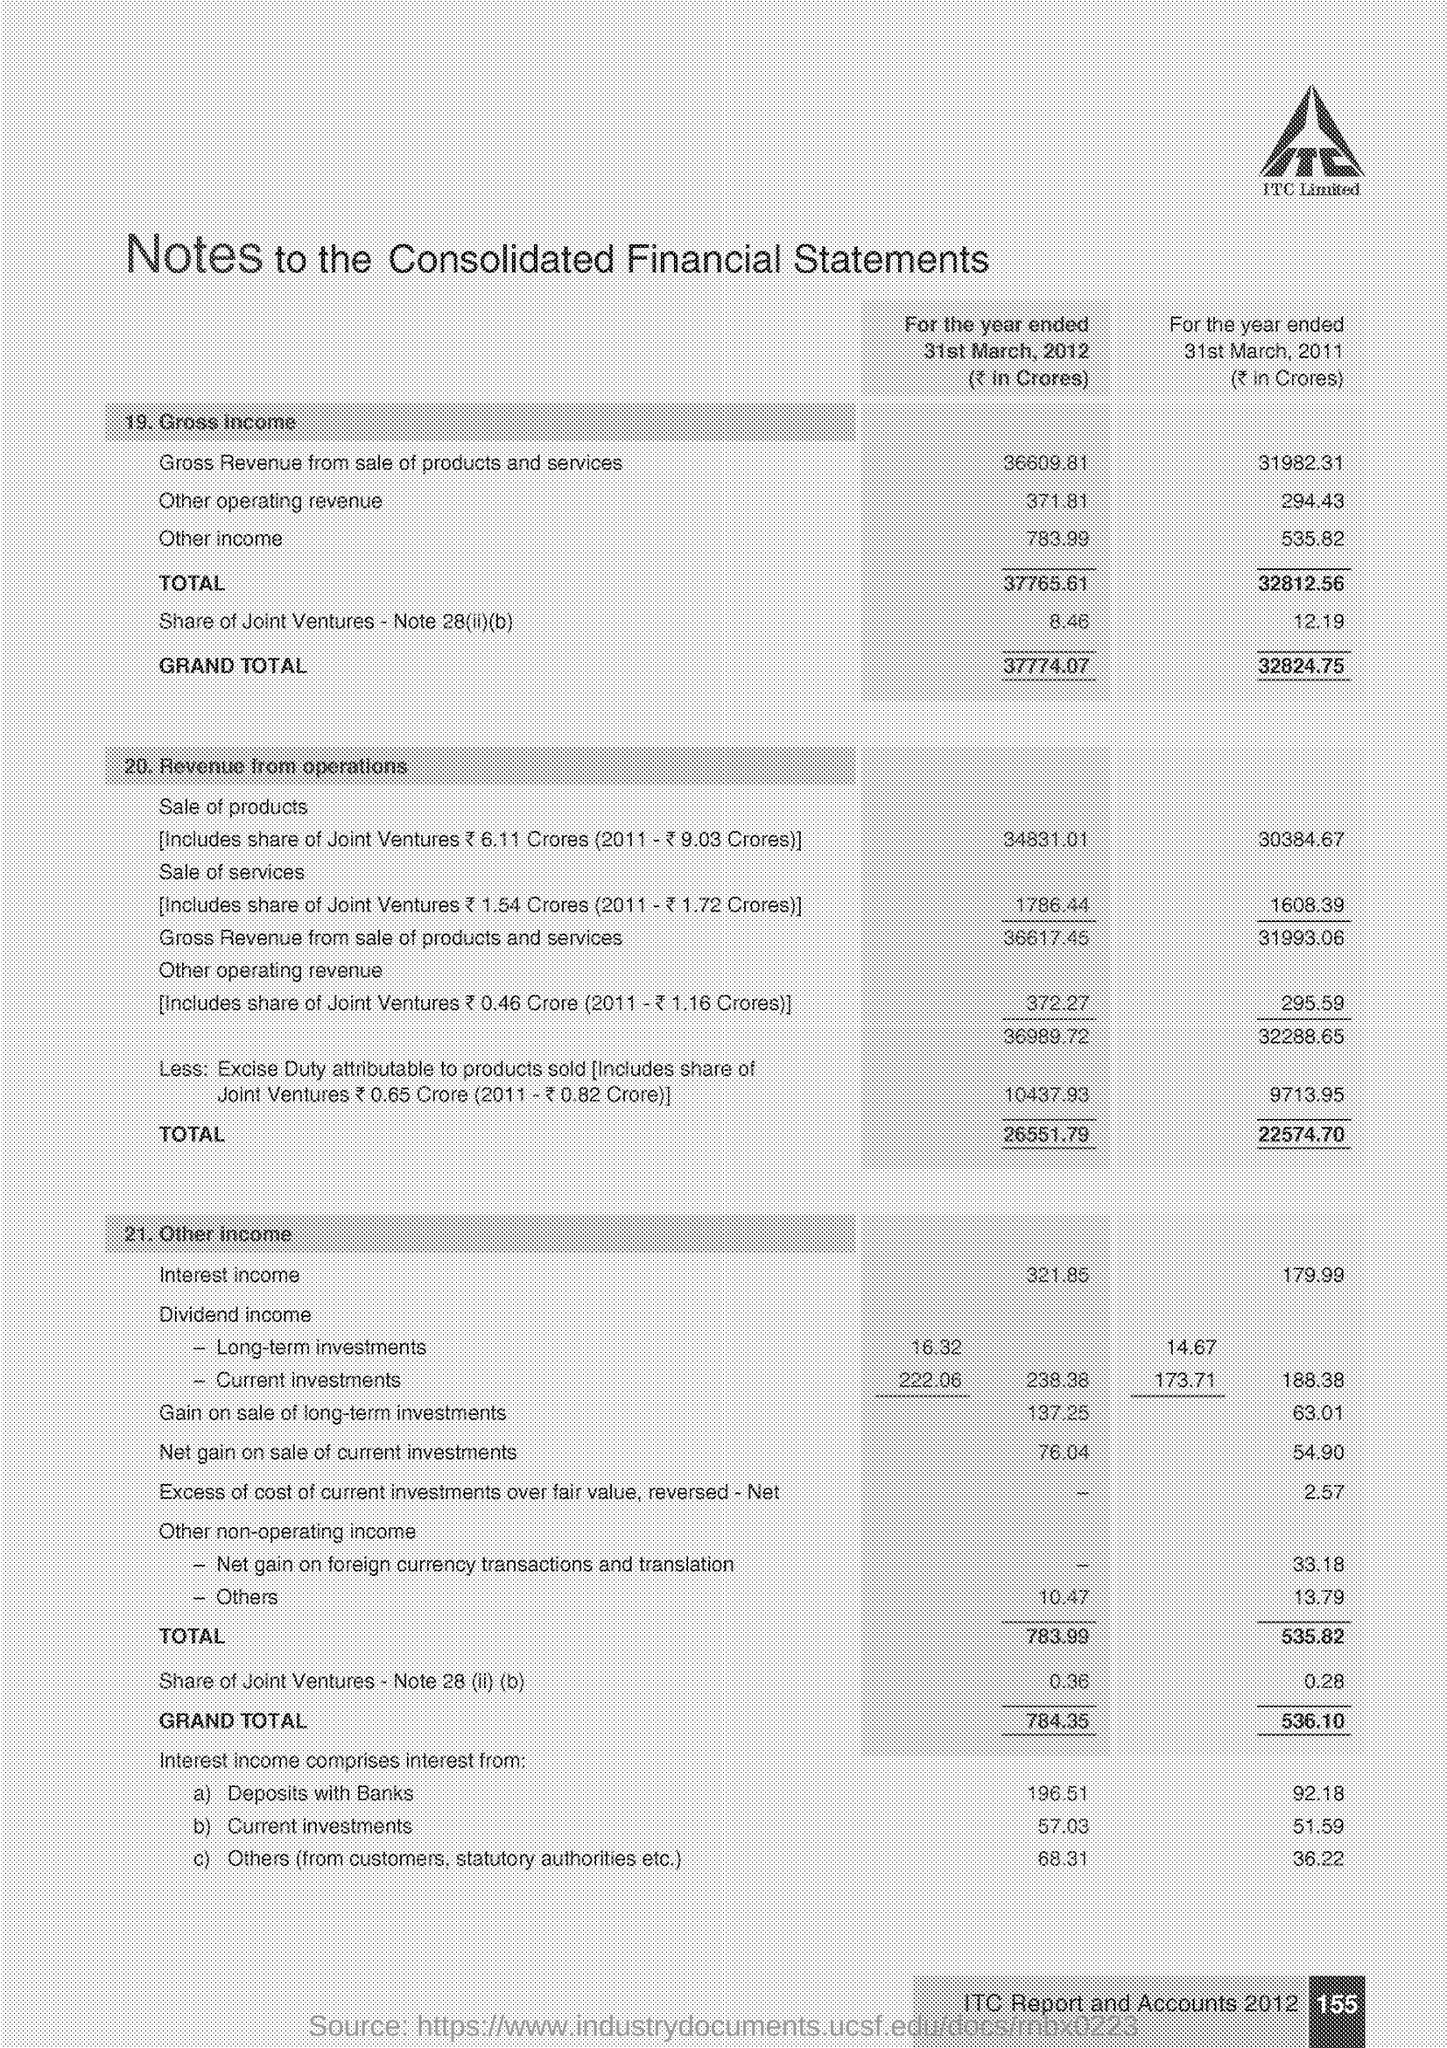What is the Company Name ?
Your response must be concise. ITC Limited. 